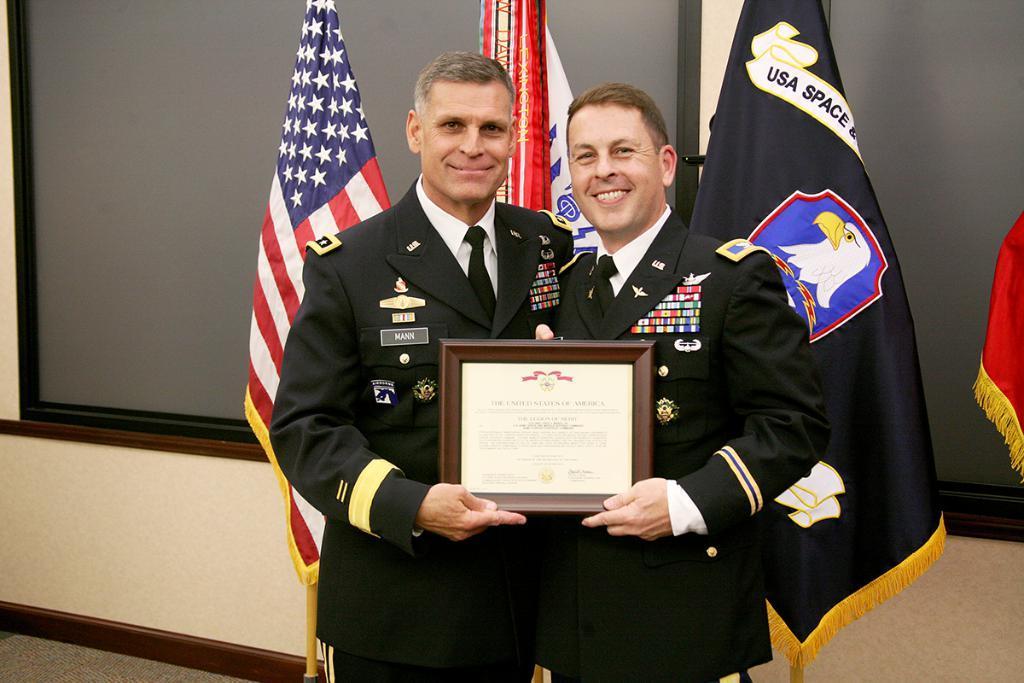How would you summarize this image in a sentence or two? In this image I can see two persons standing and holding the frame and they are wearing uniforms. In the background I can see few flags in multi color and I can also see the glass window and the wall is in cream color. 